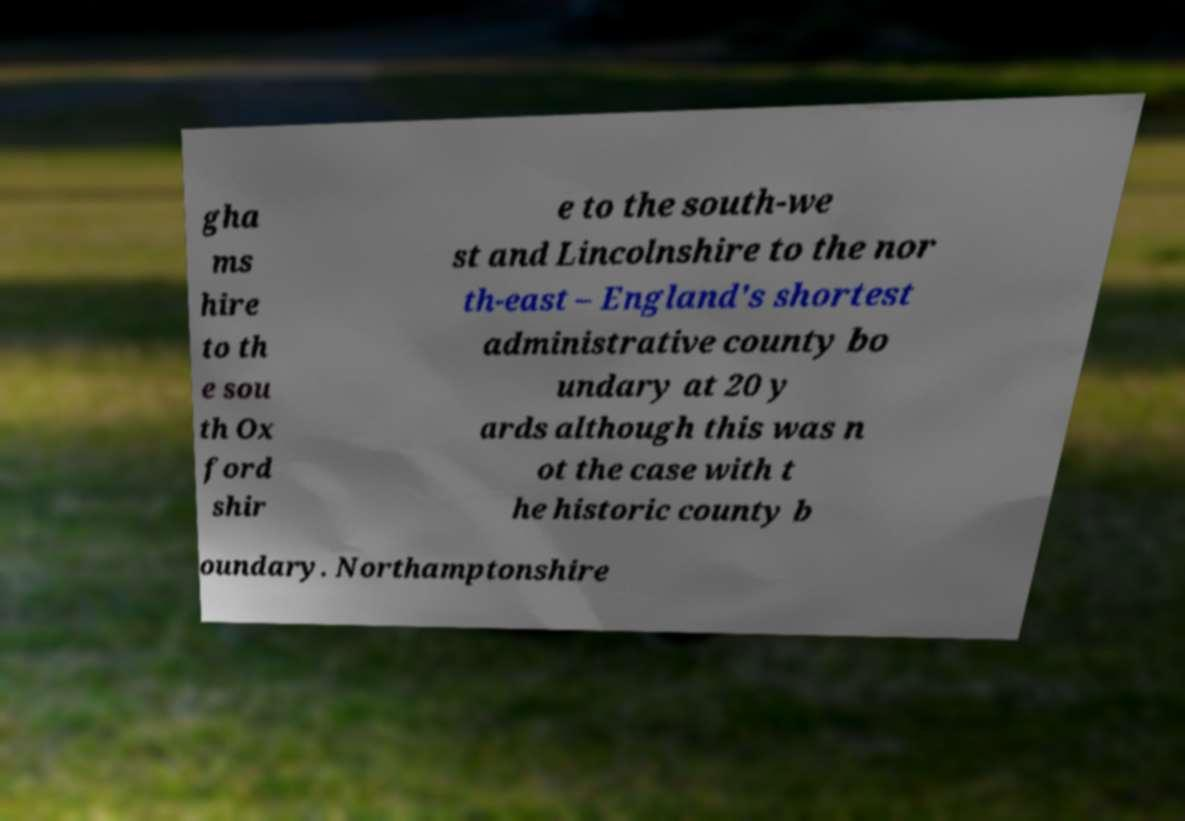Please identify and transcribe the text found in this image. gha ms hire to th e sou th Ox ford shir e to the south-we st and Lincolnshire to the nor th-east – England's shortest administrative county bo undary at 20 y ards although this was n ot the case with t he historic county b oundary. Northamptonshire 